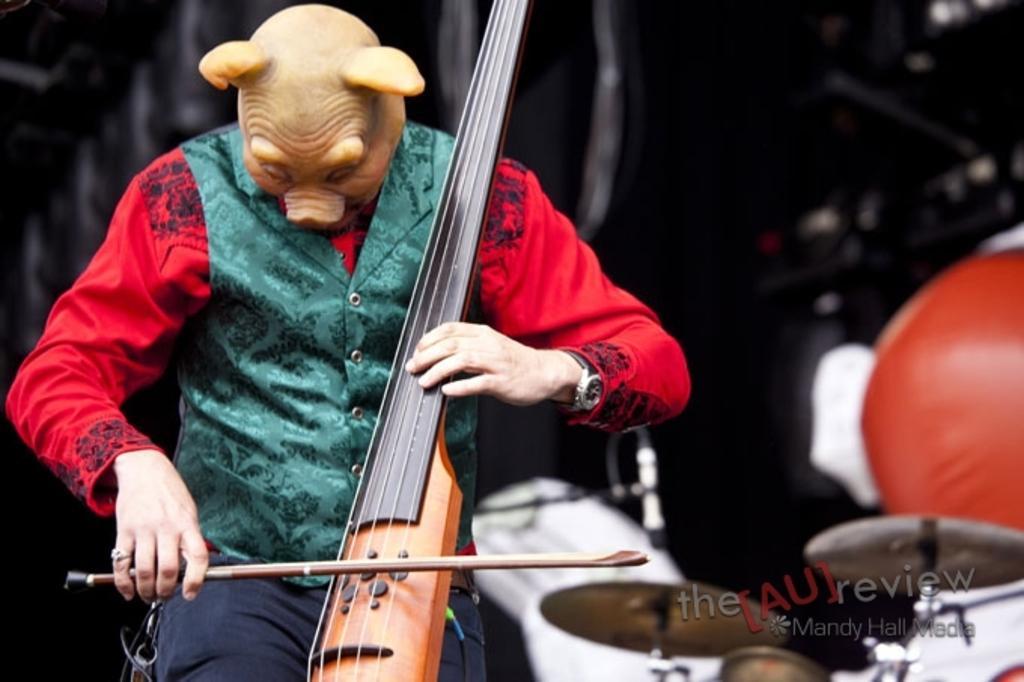In one or two sentences, can you explain what this image depicts? In this picture we can see man wore jacket, mask holding violin in his hand and playing it and beside to him we can see some more musical instruments, mic and in background it is dark. 